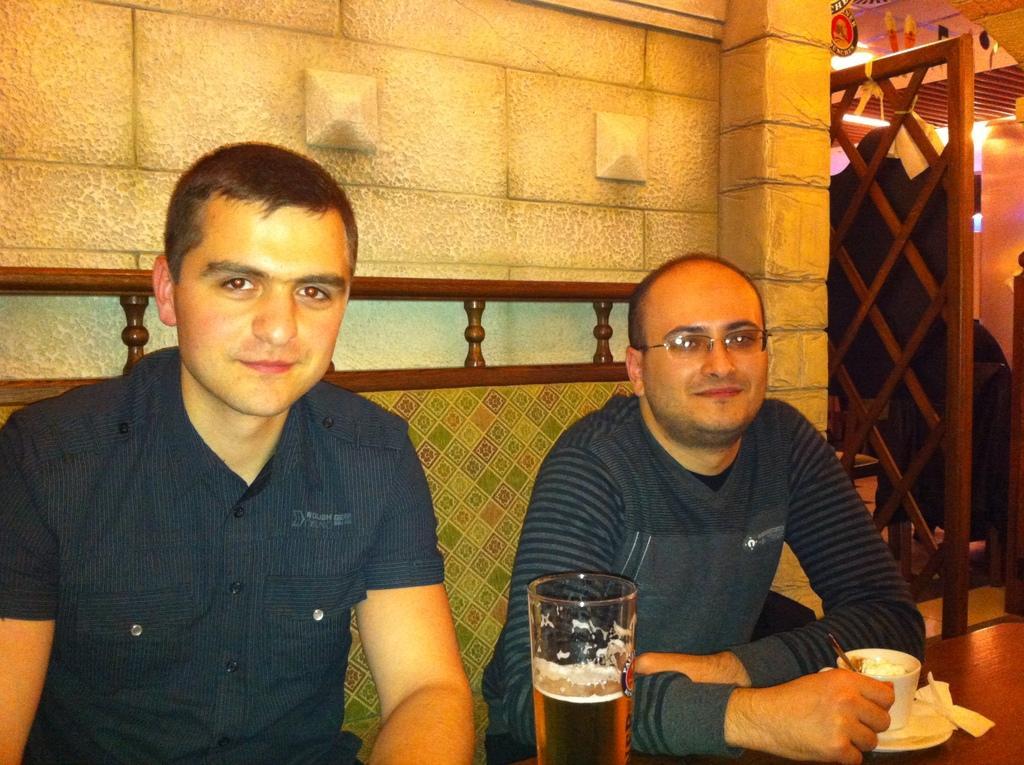In one or two sentences, can you explain what this image depicts? this picture is inside a room. There are two person sitting. they both are looking happy. both of them are wearing blue shirt. They are sitting on a sofa. In front of them there is a table on the table there is cup, plate and a glass. Beside them there is a fence. Background is wall. 